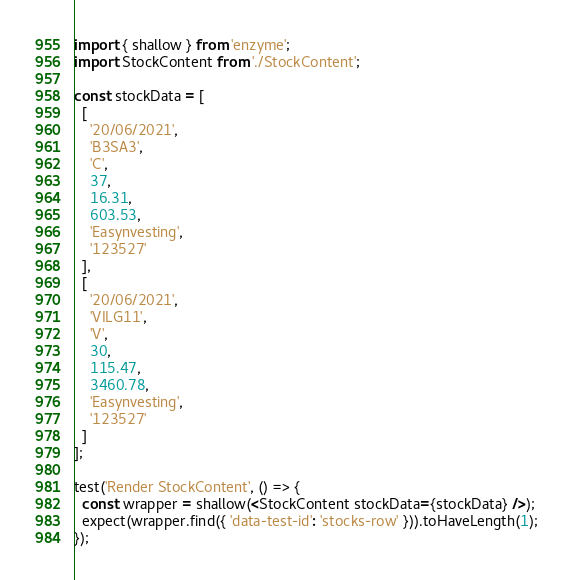<code> <loc_0><loc_0><loc_500><loc_500><_JavaScript_>import { shallow } from 'enzyme';
import StockContent from './StockContent';

const stockData = [
  [
    '20/06/2021',
    'B3SA3',
    'C',
    37,
    16.31,
    603.53,
    'Easynvesting',
    '123527'
  ],
  [
    '20/06/2021',
    'VILG11',
    'V',
    30,
    115.47,
    3460.78,
    'Easynvesting',
    '123527'
  ]
];

test('Render StockContent', () => {
  const wrapper = shallow(<StockContent stockData={stockData} />);
  expect(wrapper.find({ 'data-test-id': 'stocks-row' })).toHaveLength(1);
});
</code> 